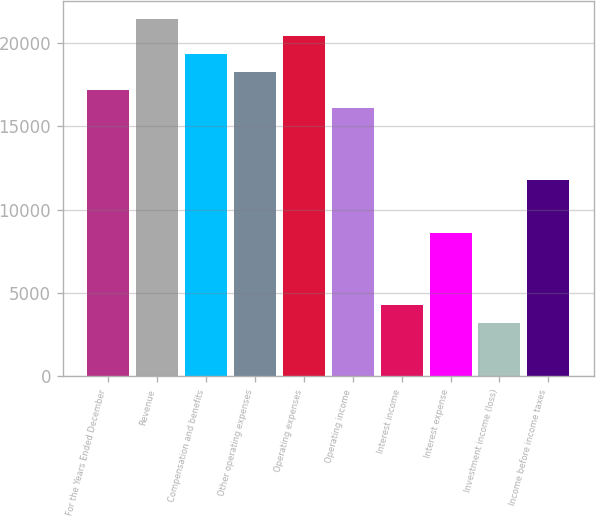<chart> <loc_0><loc_0><loc_500><loc_500><bar_chart><fcel>For the Years Ended December<fcel>Revenue<fcel>Compensation and benefits<fcel>Other operating expenses<fcel>Operating expenses<fcel>Operating income<fcel>Interest income<fcel>Interest expense<fcel>Investment income (loss)<fcel>Income before income taxes<nl><fcel>17168<fcel>21459.9<fcel>19314<fcel>18241<fcel>20386.9<fcel>16095<fcel>4292.09<fcel>8584.05<fcel>3219.1<fcel>11803<nl></chart> 